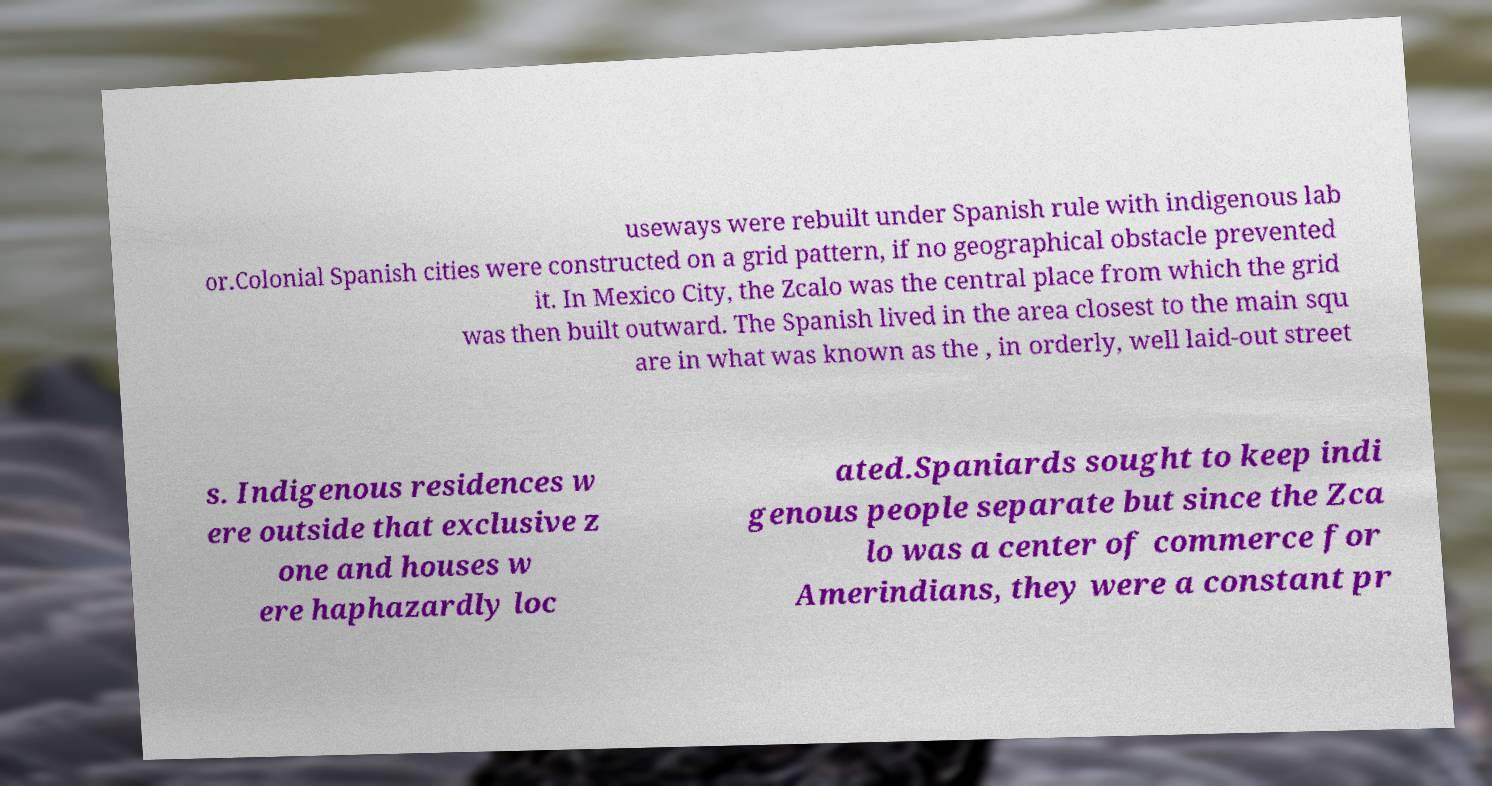Can you accurately transcribe the text from the provided image for me? useways were rebuilt under Spanish rule with indigenous lab or.Colonial Spanish cities were constructed on a grid pattern, if no geographical obstacle prevented it. In Mexico City, the Zcalo was the central place from which the grid was then built outward. The Spanish lived in the area closest to the main squ are in what was known as the , in orderly, well laid-out street s. Indigenous residences w ere outside that exclusive z one and houses w ere haphazardly loc ated.Spaniards sought to keep indi genous people separate but since the Zca lo was a center of commerce for Amerindians, they were a constant pr 